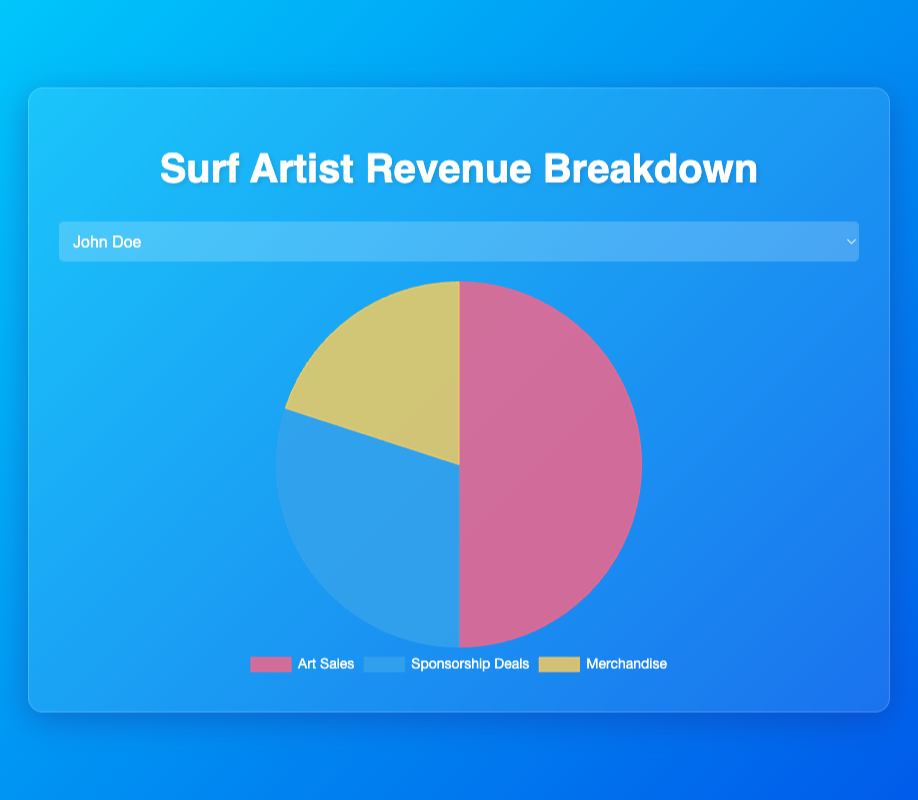Which revenue source contributes the most for John Doe? From the pie chart, visually observe the section with the largest size representing John Doe's revenue. The largest section corresponds to Art Sales.
Answer: Art Sales How much more revenue does Michael Brown make from Sponsorship Deals compared to Merchandise? Look at the pie chart for Michael Brown and note the values for Sponsorship Deals and Merchandise. Sponsorship Deals = \$40,000 and Merchandise = \$30,000. Calculate the difference: \$40,000 - \$30,000.
Answer: \$10,000 What percentage of Jane Smith's total revenue comes from Art Sales? Identify the value for Art Sales in Jane Smith's chart: \$75,000. Calculate the total revenue: \$75,000 + \$25,000 + \$15,000 = \$115,000. Then, find the percentage: (\$75,000 / \$115,000) * 100.
Answer: Approximately 65.22% Compare the revenue from Art Sales between Sarah Wilson and Emily Johnson. Who earns more, and by how much? Sarah Wilson's Art Sales = \$55,000, Emily Johnson's Art Sales = \$60,000. Calculate the difference: \$60,000 - \$55,000. Emily Johnson earns more.
Answer: Emily Johnson, by \$5,000 Which artist has the smallest portion for Merchandise in their revenue breakdown? Observe the pie chart sections for Merchandise for all artists. Jane Smith has the smallest section.
Answer: Jane Smith What is the combined revenue from Sponsorship Deals for John Doe and Sarah Wilson? Note the values: John Doe's Sponsorship Deals = \$30,000 and Sarah Wilson's Sponsorship Deals = \$45,000. Sum them: \$30,000 + \$45,000.
Answer: \$75,000 By how much does the revenue from Art Sales exceed that from Merchandise for Michael Brown? Michael Brown's Art Sales = \$80,000 and Merchandise = \$30,000. Calculate the difference: \$80,000 - \$30,000.
Answer: \$50,000 What is the average revenue from Merchandise across all artists? Sum the Merchandise values for all artists: \$20,000 (John Doe) + \$15,000 (Jane Smith) + \$25,000 (Emily Johnson) + \$30,000 (Michael Brown) + \$20,000 (Sarah Wilson) = \$110,000. There are 5 artists, so divide: \$110,000 / 5.
Answer: \$22,000 